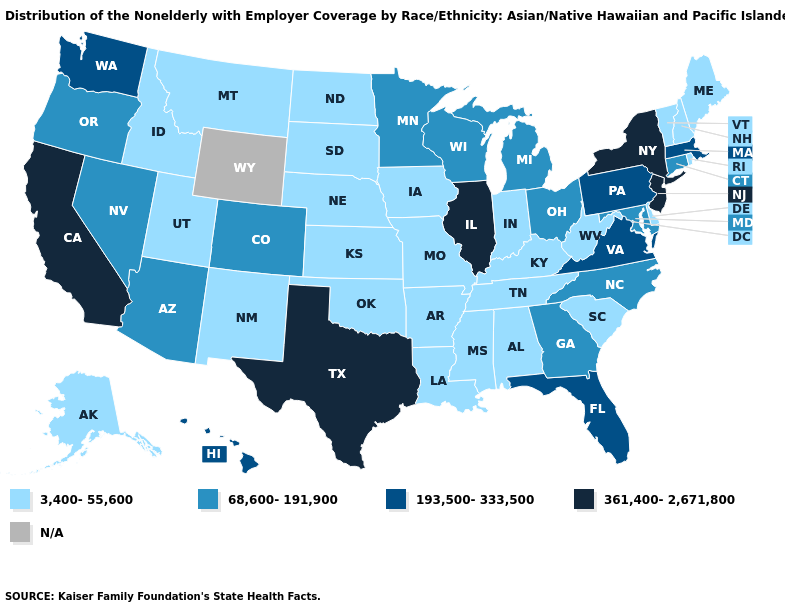What is the highest value in the South ?
Quick response, please. 361,400-2,671,800. Which states hav the highest value in the West?
Write a very short answer. California. What is the highest value in the USA?
Quick response, please. 361,400-2,671,800. Name the states that have a value in the range 193,500-333,500?
Short answer required. Florida, Hawaii, Massachusetts, Pennsylvania, Virginia, Washington. Which states have the lowest value in the USA?
Keep it brief. Alabama, Alaska, Arkansas, Delaware, Idaho, Indiana, Iowa, Kansas, Kentucky, Louisiana, Maine, Mississippi, Missouri, Montana, Nebraska, New Hampshire, New Mexico, North Dakota, Oklahoma, Rhode Island, South Carolina, South Dakota, Tennessee, Utah, Vermont, West Virginia. What is the lowest value in the USA?
Keep it brief. 3,400-55,600. Does Washington have the highest value in the USA?
Write a very short answer. No. What is the value of Illinois?
Keep it brief. 361,400-2,671,800. Name the states that have a value in the range N/A?
Give a very brief answer. Wyoming. Which states have the lowest value in the Northeast?
Give a very brief answer. Maine, New Hampshire, Rhode Island, Vermont. 